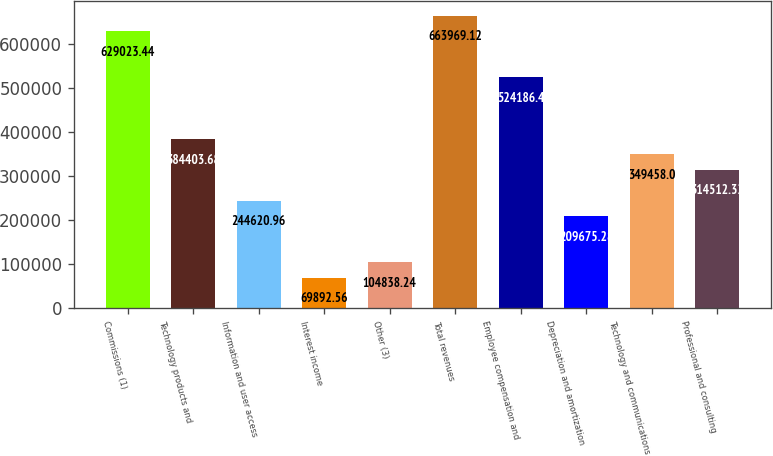<chart> <loc_0><loc_0><loc_500><loc_500><bar_chart><fcel>Commissions (1)<fcel>Technology products and<fcel>Information and user access<fcel>Interest income<fcel>Other (3)<fcel>Total revenues<fcel>Employee compensation and<fcel>Depreciation and amortization<fcel>Technology and communications<fcel>Professional and consulting<nl><fcel>629023<fcel>384404<fcel>244621<fcel>69892.6<fcel>104838<fcel>663969<fcel>524186<fcel>209675<fcel>349458<fcel>314512<nl></chart> 